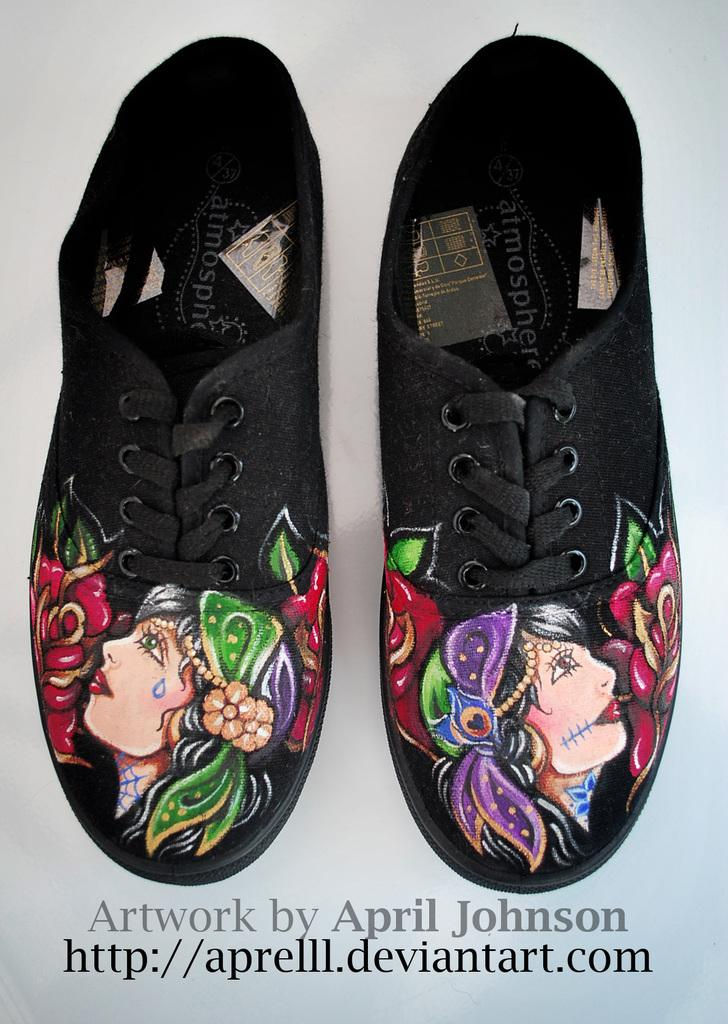What type of footwear is featured in the image? There are two black color shoes in the image. Where are the shoes located in the image? The shoes are in the center of the image. What hobbies do the robins in the image enjoy? There are no robins present in the image; it features two black color shoes. 